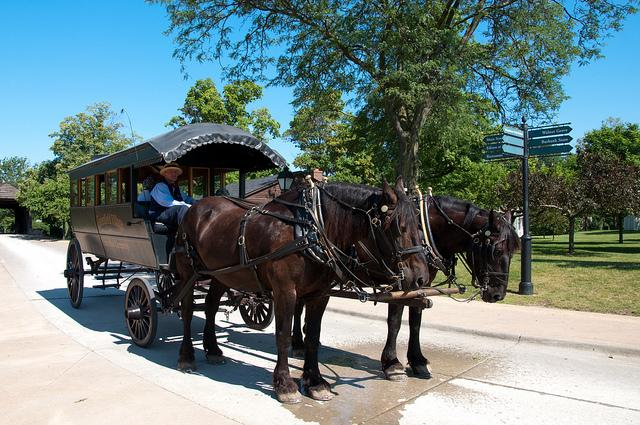What is the green item near the horses? Please explain your reasoning. sign. It's a sign so you know what way you need to go. 